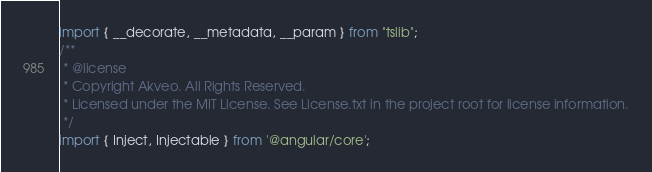<code> <loc_0><loc_0><loc_500><loc_500><_JavaScript_>import { __decorate, __metadata, __param } from "tslib";
/**
 * @license
 * Copyright Akveo. All Rights Reserved.
 * Licensed under the MIT License. See License.txt in the project root for license information.
 */
import { Inject, Injectable } from '@angular/core';</code> 